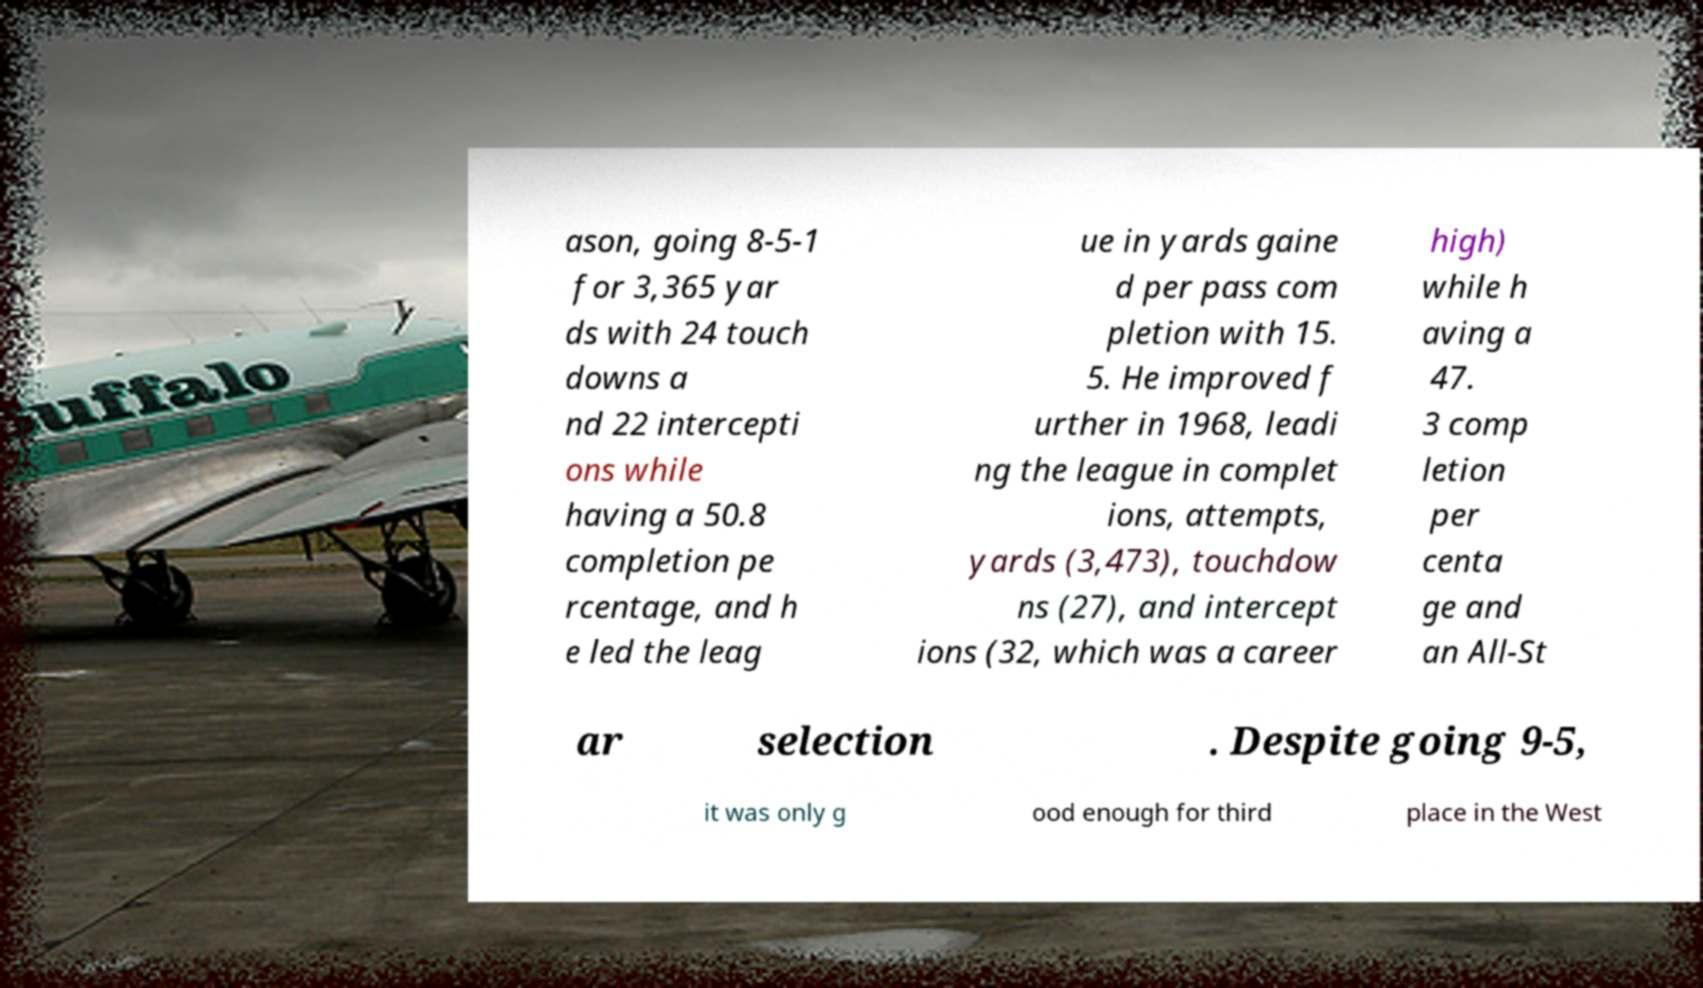Could you extract and type out the text from this image? ason, going 8-5-1 for 3,365 yar ds with 24 touch downs a nd 22 intercepti ons while having a 50.8 completion pe rcentage, and h e led the leag ue in yards gaine d per pass com pletion with 15. 5. He improved f urther in 1968, leadi ng the league in complet ions, attempts, yards (3,473), touchdow ns (27), and intercept ions (32, which was a career high) while h aving a 47. 3 comp letion per centa ge and an All-St ar selection . Despite going 9-5, it was only g ood enough for third place in the West 